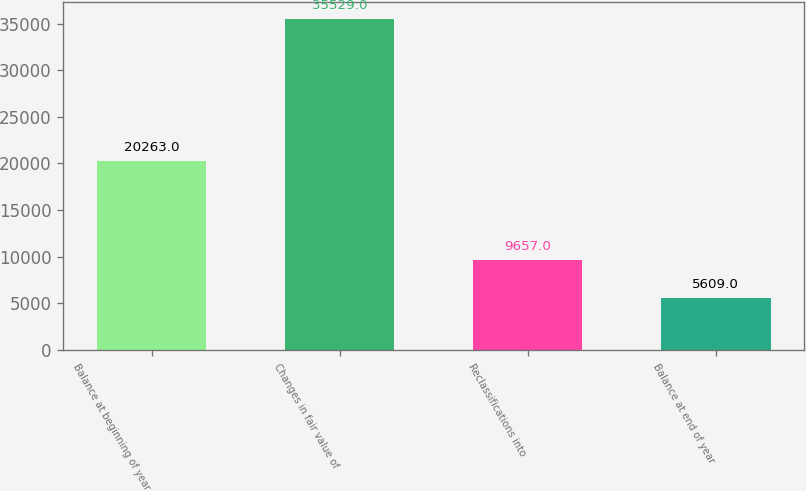Convert chart. <chart><loc_0><loc_0><loc_500><loc_500><bar_chart><fcel>Balance at beginning of year<fcel>Changes in fair value of<fcel>Reclassifications into<fcel>Balance at end of year<nl><fcel>20263<fcel>35529<fcel>9657<fcel>5609<nl></chart> 